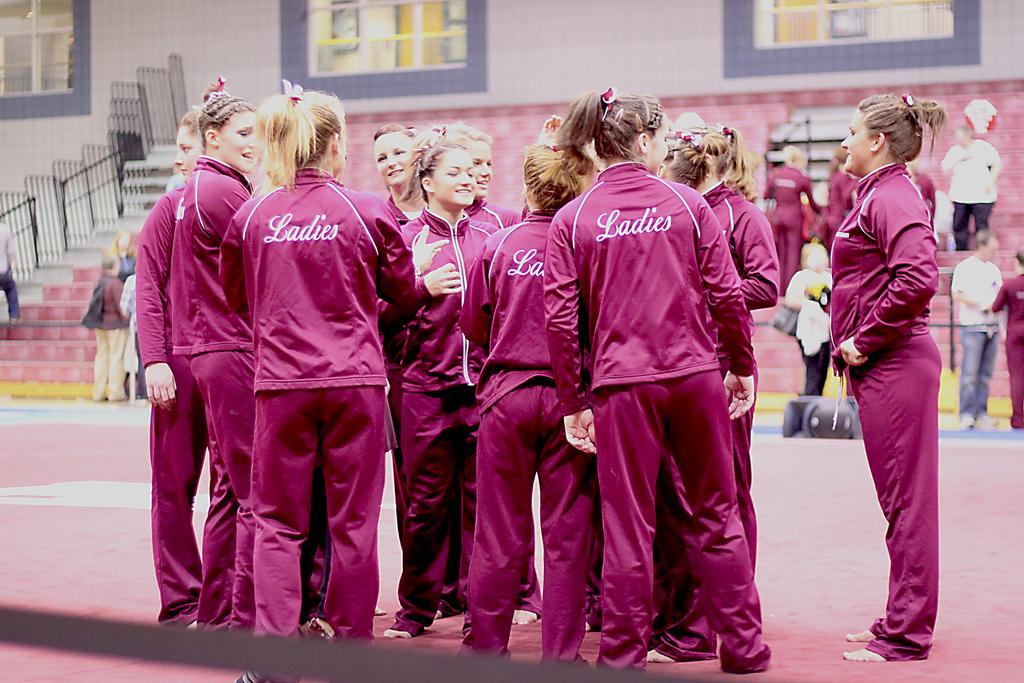<image>
Relay a brief, clear account of the picture shown. Women wearing pink jumpsuits with "Ladies" on the back are gathered around. 